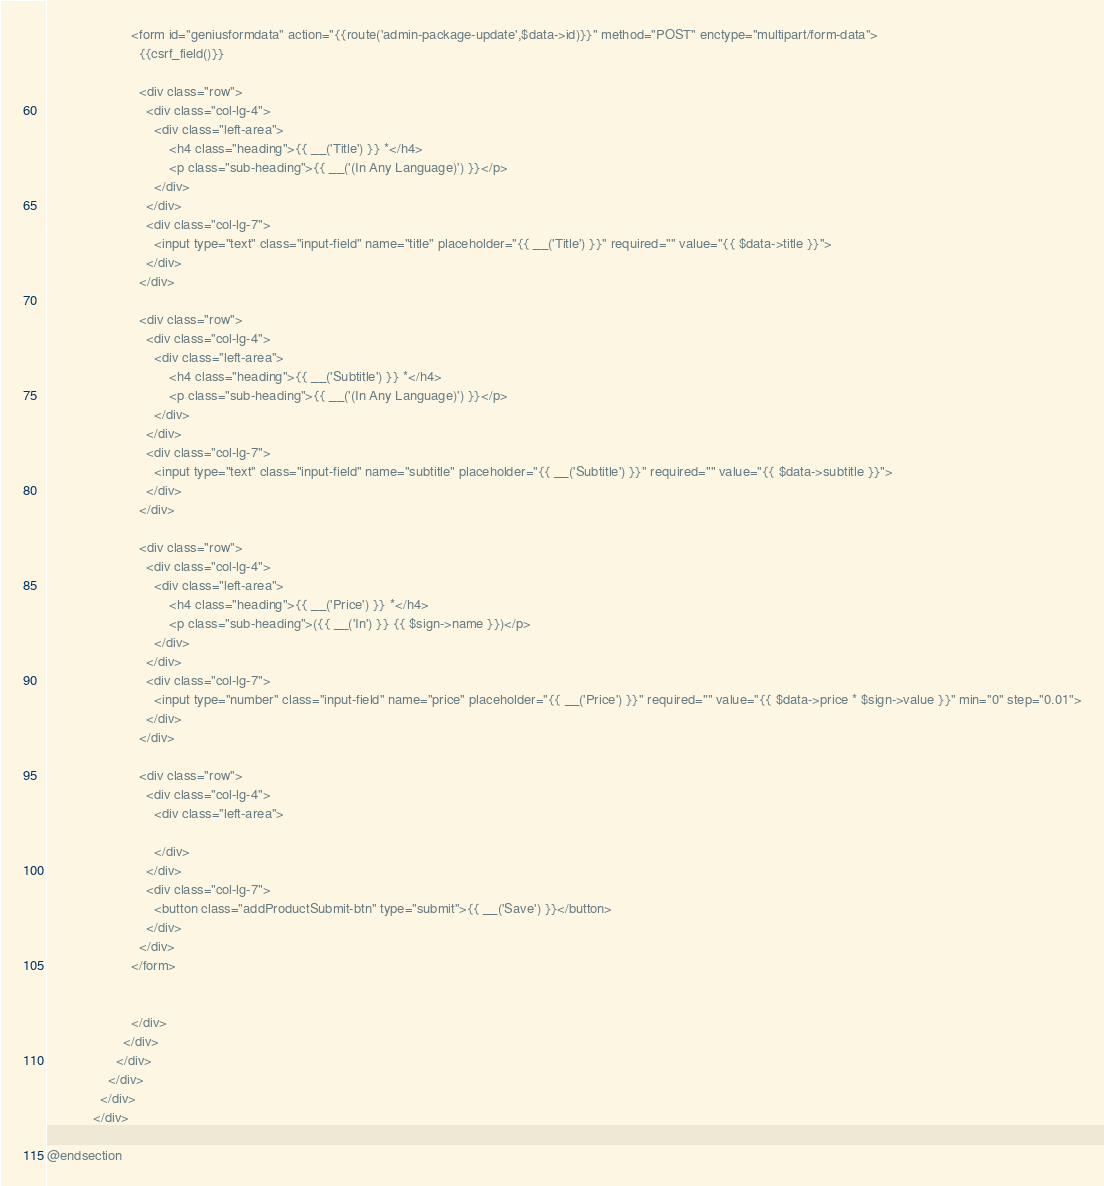<code> <loc_0><loc_0><loc_500><loc_500><_PHP_>                      <form id="geniusformdata" action="{{route('admin-package-update',$data->id)}}" method="POST" enctype="multipart/form-data">
                        {{csrf_field()}}

                        <div class="row">
                          <div class="col-lg-4">
                            <div class="left-area">
                                <h4 class="heading">{{ __('Title') }} *</h4>
                                <p class="sub-heading">{{ __('(In Any Language)') }}</p>
                            </div>
                          </div>
                          <div class="col-lg-7">
                            <input type="text" class="input-field" name="title" placeholder="{{ __('Title') }}" required="" value="{{ $data->title }}">
                          </div>
                        </div>

                        <div class="row">
                          <div class="col-lg-4">
                            <div class="left-area">
                                <h4 class="heading">{{ __('Subtitle') }} *</h4>
                                <p class="sub-heading">{{ __('(In Any Language)') }}</p>
                            </div>
                          </div>
                          <div class="col-lg-7">
                            <input type="text" class="input-field" name="subtitle" placeholder="{{ __('Subtitle') }}" required="" value="{{ $data->subtitle }}">
                          </div>
                        </div>

                        <div class="row">
                          <div class="col-lg-4">
                            <div class="left-area">
                                <h4 class="heading">{{ __('Price') }} *</h4>
                                <p class="sub-heading">({{ __('In') }} {{ $sign->name }})</p>
                            </div>
                          </div>
                          <div class="col-lg-7">
                            <input type="number" class="input-field" name="price" placeholder="{{ __('Price') }}" required="" value="{{ $data->price * $sign->value }}" min="0" step="0.01">
                          </div>
                        </div>

                        <div class="row">
                          <div class="col-lg-4">
                            <div class="left-area">
                              
                            </div>
                          </div>
                          <div class="col-lg-7">
                            <button class="addProductSubmit-btn" type="submit">{{ __('Save') }}</button>
                          </div>
                        </div>
                      </form>


                      </div>
                    </div>
                  </div>
                </div>
              </div>
            </div>

@endsection</code> 